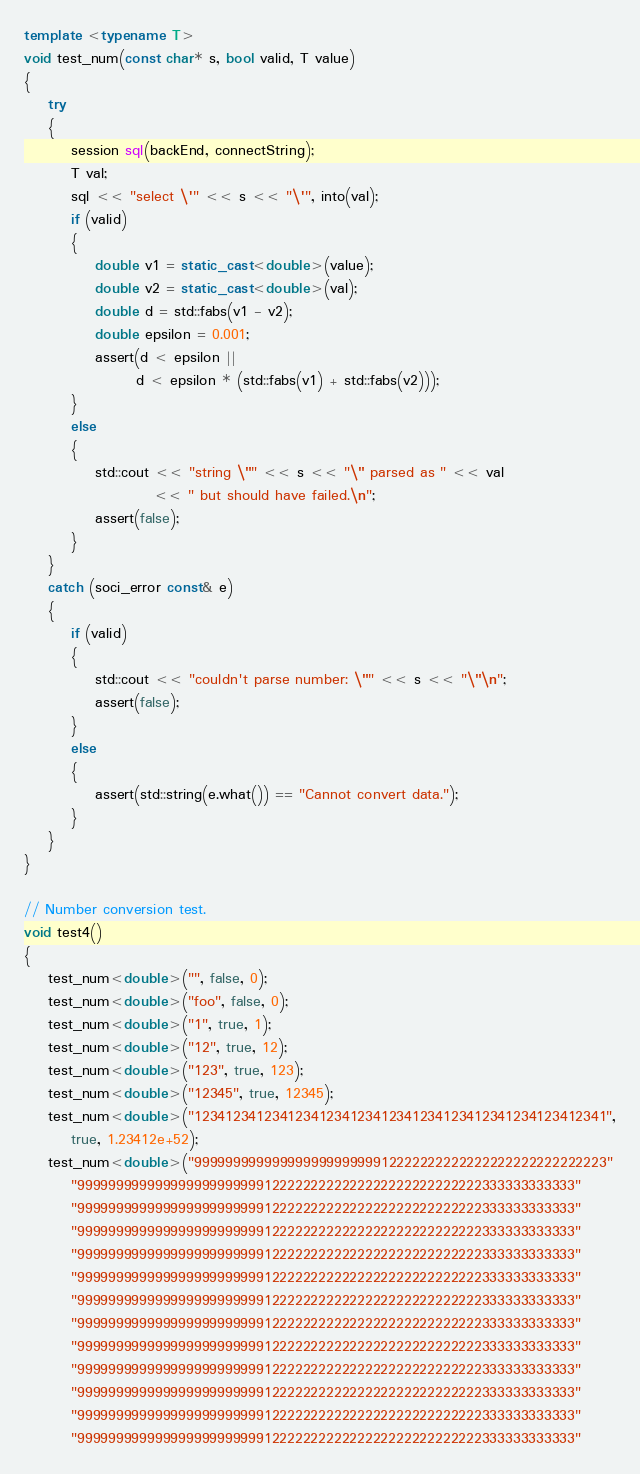<code> <loc_0><loc_0><loc_500><loc_500><_C++_>
template <typename T>
void test_num(const char* s, bool valid, T value)
{
    try
    {
        session sql(backEnd, connectString);
        T val;
        sql << "select \'" << s << "\'", into(val);
        if (valid)
        {
            double v1 = static_cast<double>(value);
            double v2 = static_cast<double>(val);
            double d = std::fabs(v1 - v2);
            double epsilon = 0.001;
            assert(d < epsilon ||
                   d < epsilon * (std::fabs(v1) + std::fabs(v2)));
        }
        else
        {
            std::cout << "string \"" << s << "\" parsed as " << val
                      << " but should have failed.\n";
            assert(false);
        }
    }
    catch (soci_error const& e)
    {
        if (valid)
        {
            std::cout << "couldn't parse number: \"" << s << "\"\n";
            assert(false);
        }
        else
        {
            assert(std::string(e.what()) == "Cannot convert data.");
        }
    }
}

// Number conversion test.
void test4()
{
    test_num<double>("", false, 0);
    test_num<double>("foo", false, 0);
    test_num<double>("1", true, 1);
    test_num<double>("12", true, 12);
    test_num<double>("123", true, 123);
    test_num<double>("12345", true, 12345);
    test_num<double>("12341234123412341234123412341234123412341234123412341",
        true, 1.23412e+52);
    test_num<double>("99999999999999999999999912222222222222222222222222223"
        "9999999999999999999999991222222222222222222222222222333333333333"
        "9999999999999999999999991222222222222222222222222222333333333333"
        "9999999999999999999999991222222222222222222222222222333333333333"
        "9999999999999999999999991222222222222222222222222222333333333333"
        "9999999999999999999999991222222222222222222222222222333333333333"
        "9999999999999999999999991222222222222222222222222222333333333333"
        "9999999999999999999999991222222222222222222222222222333333333333"
        "9999999999999999999999991222222222222222222222222222333333333333"
        "9999999999999999999999991222222222222222222222222222333333333333"
        "9999999999999999999999991222222222222222222222222222333333333333"
        "9999999999999999999999991222222222222222222222222222333333333333"
        "9999999999999999999999991222222222222222222222222222333333333333"</code> 